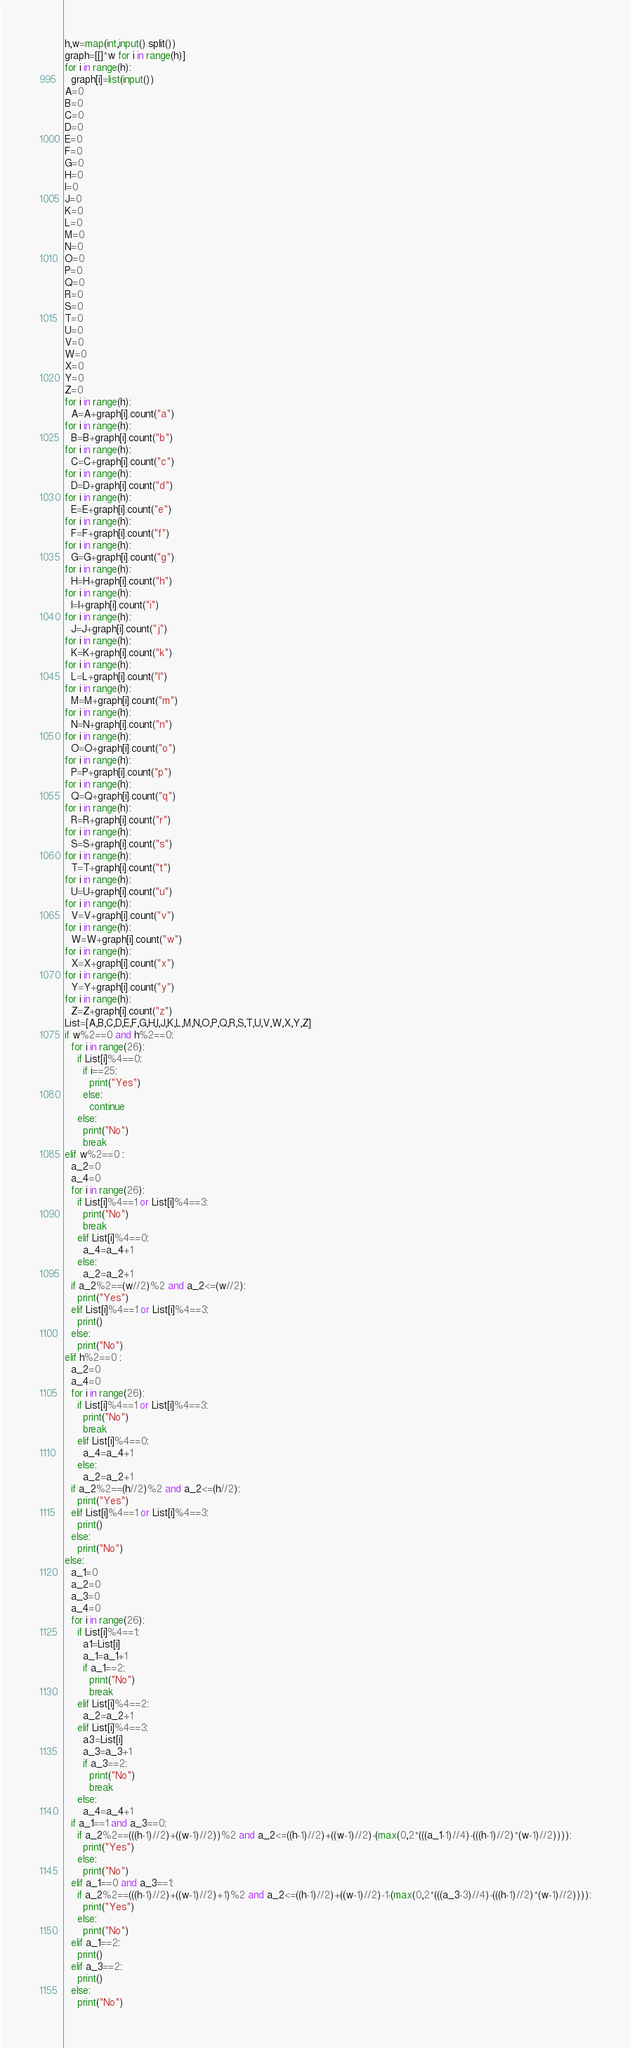Convert code to text. <code><loc_0><loc_0><loc_500><loc_500><_Python_>h,w=map(int,input().split())
graph=[[]*w for i in range(h)]
for i in range(h):
  graph[i]=list(input())
A=0
B=0
C=0
D=0
E=0
F=0
G=0
H=0
I=0
J=0
K=0
L=0
M=0
N=0
O=0
P=0
Q=0
R=0
S=0
T=0
U=0
V=0
W=0
X=0
Y=0
Z=0
for i in range(h):
  A=A+graph[i].count("a")
for i in range(h):
  B=B+graph[i].count("b")
for i in range(h):
  C=C+graph[i].count("c")
for i in range(h):
  D=D+graph[i].count("d")
for i in range(h):
  E=E+graph[i].count("e")
for i in range(h):
  F=F+graph[i].count("f")
for i in range(h):
  G=G+graph[i].count("g")
for i in range(h):
  H=H+graph[i].count("h")
for i in range(h):
  I=I+graph[i].count("i")
for i in range(h):
  J=J+graph[i].count("j")
for i in range(h):
  K=K+graph[i].count("k")
for i in range(h):
  L=L+graph[i].count("l")
for i in range(h):
  M=M+graph[i].count("m")
for i in range(h):
  N=N+graph[i].count("n")
for i in range(h):
  O=O+graph[i].count("o")
for i in range(h):
  P=P+graph[i].count("p")
for i in range(h):
  Q=Q+graph[i].count("q")
for i in range(h):
  R=R+graph[i].count("r")
for i in range(h):
  S=S+graph[i].count("s")
for i in range(h):
  T=T+graph[i].count("t")
for i in range(h):
  U=U+graph[i].count("u")
for i in range(h):
  V=V+graph[i].count("v")
for i in range(h):
  W=W+graph[i].count("w")
for i in range(h):
  X=X+graph[i].count("x")
for i in range(h):
  Y=Y+graph[i].count("y")
for i in range(h):
  Z=Z+graph[i].count("z")
List=[A,B,C,D,E,F,G,H,I,J,K,L,M,N,O,P,Q,R,S,T,U,V,W,X,Y,Z]
if w%2==0 and h%2==0:
  for i in range(26):
    if List[i]%4==0:
      if i==25:
        print("Yes")
      else:
        continue
    else:
      print("No")
      break
elif w%2==0 :
  a_2=0
  a_4=0
  for i in range(26):
    if List[i]%4==1 or List[i]%4==3:
      print("No")
      break
    elif List[i]%4==0:
      a_4=a_4+1
    else:
      a_2=a_2+1
  if a_2%2==(w//2)%2 and a_2<=(w//2):
    print("Yes")
  elif List[i]%4==1 or List[i]%4==3:
    print()
  else:
    print("No")
elif h%2==0 :
  a_2=0
  a_4=0
  for i in range(26):
    if List[i]%4==1 or List[i]%4==3:
      print("No")
      break
    elif List[i]%4==0:
      a_4=a_4+1
    else:
      a_2=a_2+1
  if a_2%2==(h//2)%2 and a_2<=(h//2):
    print("Yes")
  elif List[i]%4==1 or List[i]%4==3:
    print()
  else:
    print("No")
else:
  a_1=0
  a_2=0
  a_3=0
  a_4=0
  for i in range(26):
    if List[i]%4==1:
      a1=List[i]
      a_1=a_1+1
      if a_1==2:
        print("No")
        break
    elif List[i]%4==2:
      a_2=a_2+1
    elif List[i]%4==3:
      a3=List[i]
      a_3=a_3+1
      if a_3==2:
        print("No")
        break
    else:
      a_4=a_4+1
  if a_1==1 and a_3==0:
    if a_2%2==(((h-1)//2)+((w-1)//2))%2 and a_2<=((h-1)//2)+((w-1)//2)-(max(0,2*(((a_1-1)//4)-(((h-1)//2)*(w-1)//2)))):
      print("Yes")
    else:
      print("No")
  elif a_1==0 and a_3==1:
    if a_2%2==(((h-1)//2)+((w-1)//2)+1)%2 and a_2<=((h-1)//2)+((w-1)//2)-1-(max(0,2*(((a_3-3)//4)-(((h-1)//2)*(w-1)//2)))):
      print("Yes")
    else:
      print("No")
  elif a_1==2:
    print()
  elif a_3==2:
    print()
  else:
    print("No")</code> 